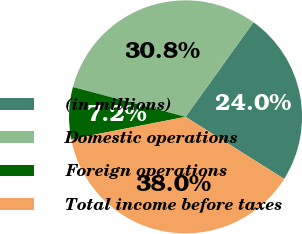Convert chart. <chart><loc_0><loc_0><loc_500><loc_500><pie_chart><fcel>(in millions)<fcel>Domestic operations<fcel>Foreign operations<fcel>Total income before taxes<nl><fcel>24.02%<fcel>30.8%<fcel>7.19%<fcel>37.99%<nl></chart> 